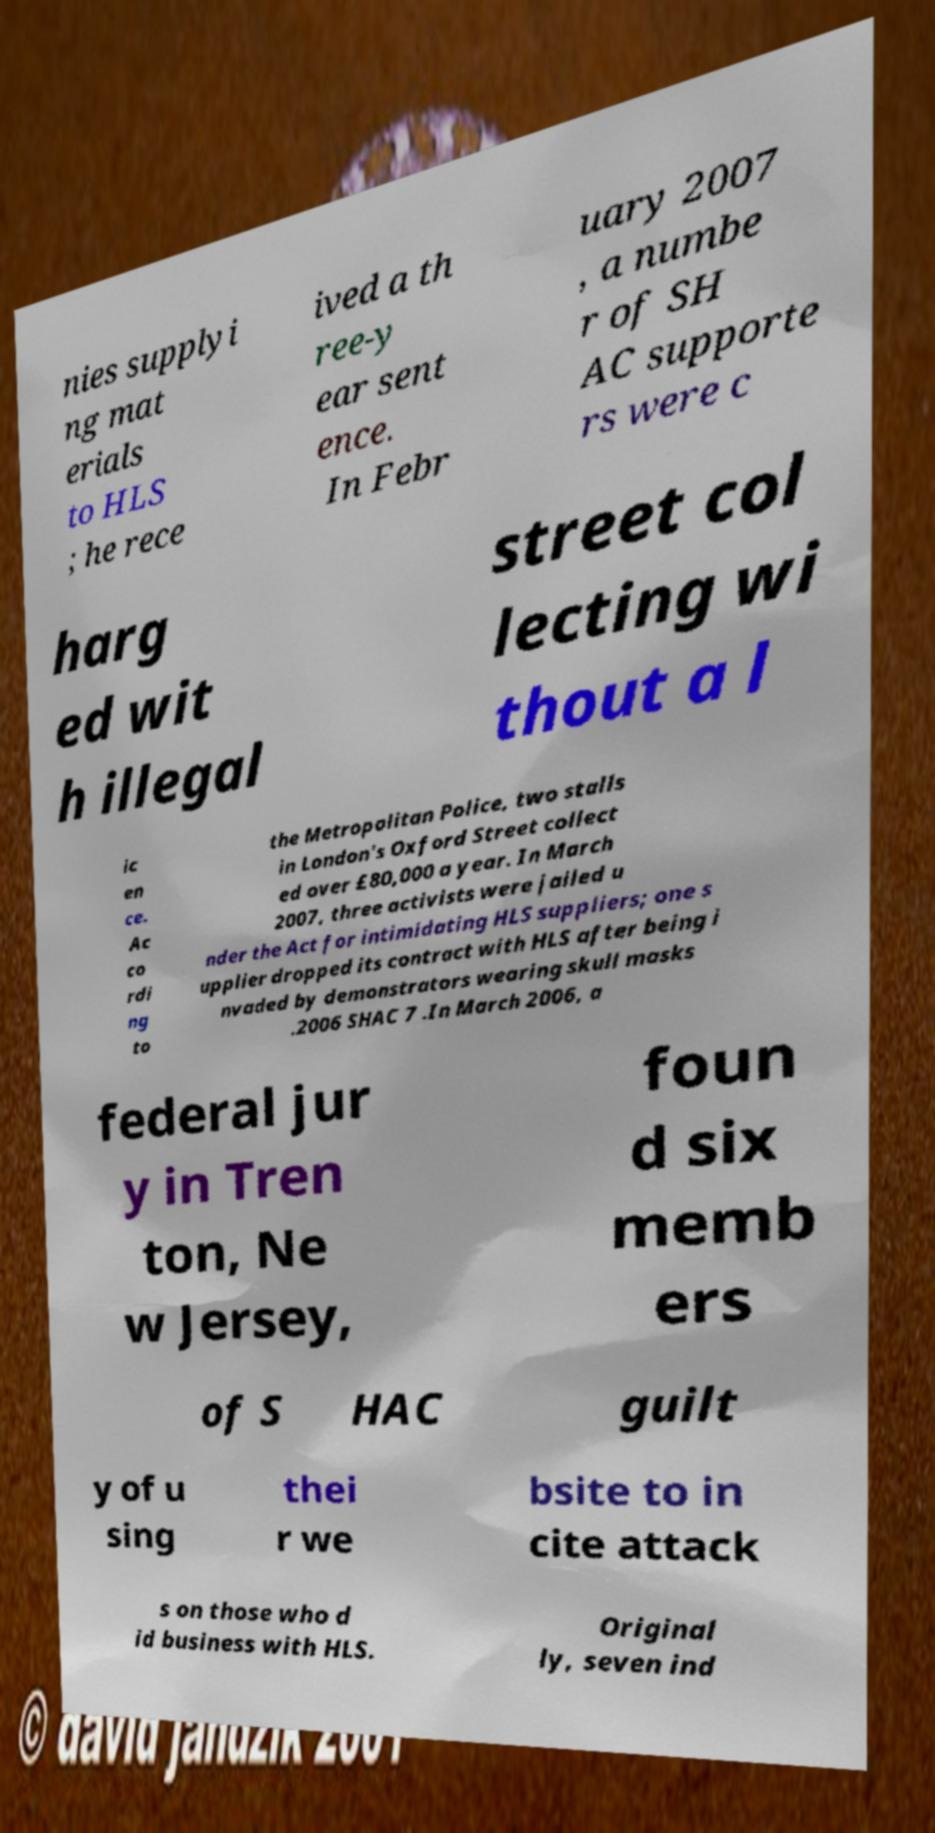For documentation purposes, I need the text within this image transcribed. Could you provide that? nies supplyi ng mat erials to HLS ; he rece ived a th ree-y ear sent ence. In Febr uary 2007 , a numbe r of SH AC supporte rs were c harg ed wit h illegal street col lecting wi thout a l ic en ce. Ac co rdi ng to the Metropolitan Police, two stalls in London's Oxford Street collect ed over £80,000 a year. In March 2007, three activists were jailed u nder the Act for intimidating HLS suppliers; one s upplier dropped its contract with HLS after being i nvaded by demonstrators wearing skull masks .2006 SHAC 7 .In March 2006, a federal jur y in Tren ton, Ne w Jersey, foun d six memb ers of S HAC guilt y of u sing thei r we bsite to in cite attack s on those who d id business with HLS. Original ly, seven ind 